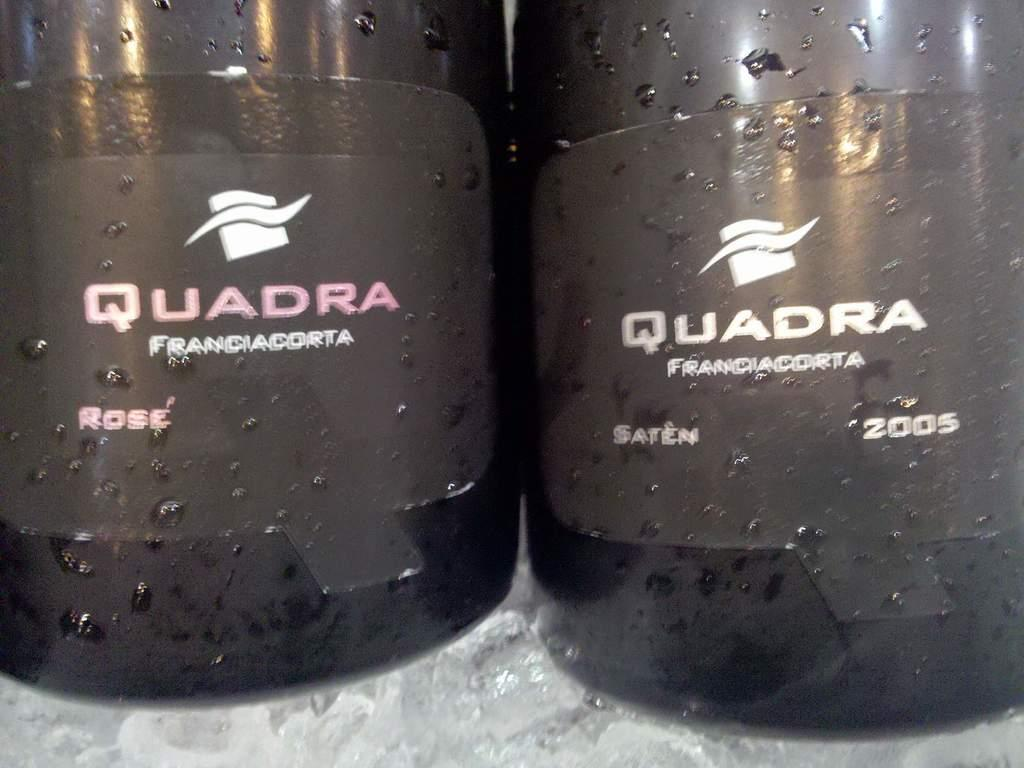<image>
Relay a brief, clear account of the picture shown. Two bottles of Quadra wine sitting beside each other. 